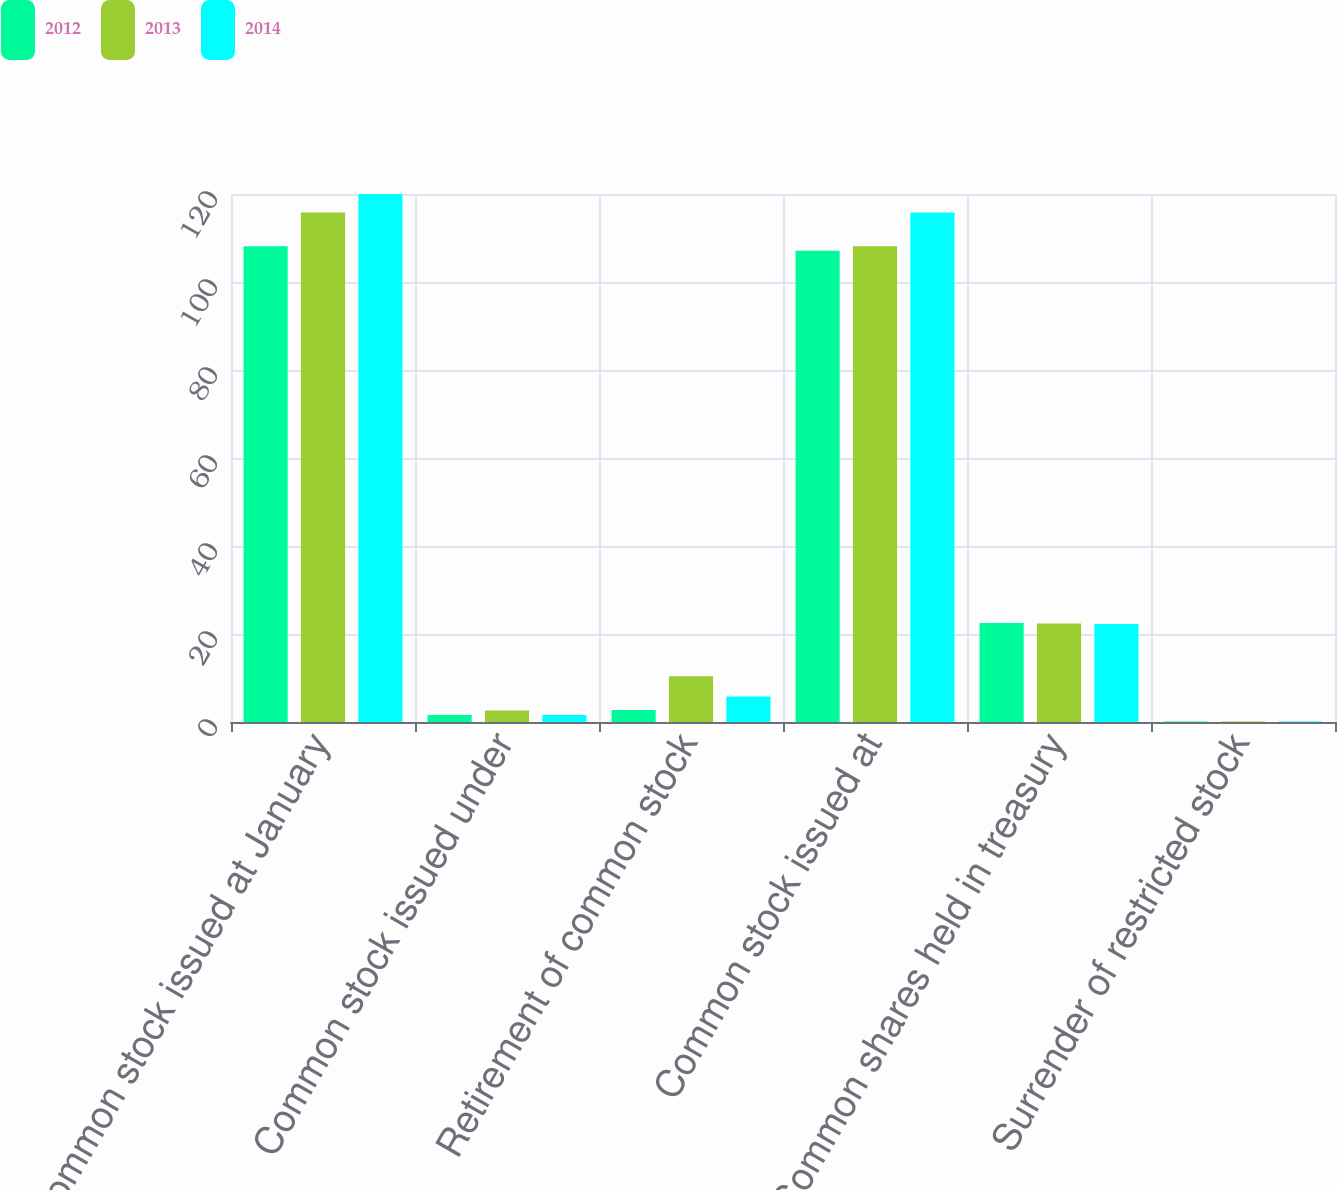<chart> <loc_0><loc_0><loc_500><loc_500><stacked_bar_chart><ecel><fcel>Common stock issued at January<fcel>Common stock issued under<fcel>Retirement of common stock<fcel>Common stock issued at<fcel>Common shares held in treasury<fcel>Surrender of restricted stock<nl><fcel>2012<fcel>108.1<fcel>1.6<fcel>2.7<fcel>107.1<fcel>22.5<fcel>0.1<nl><fcel>2013<fcel>115.8<fcel>2.6<fcel>10.4<fcel>108.1<fcel>22.4<fcel>0.1<nl><fcel>2014<fcel>120<fcel>1.6<fcel>5.8<fcel>115.8<fcel>22.3<fcel>0.1<nl></chart> 